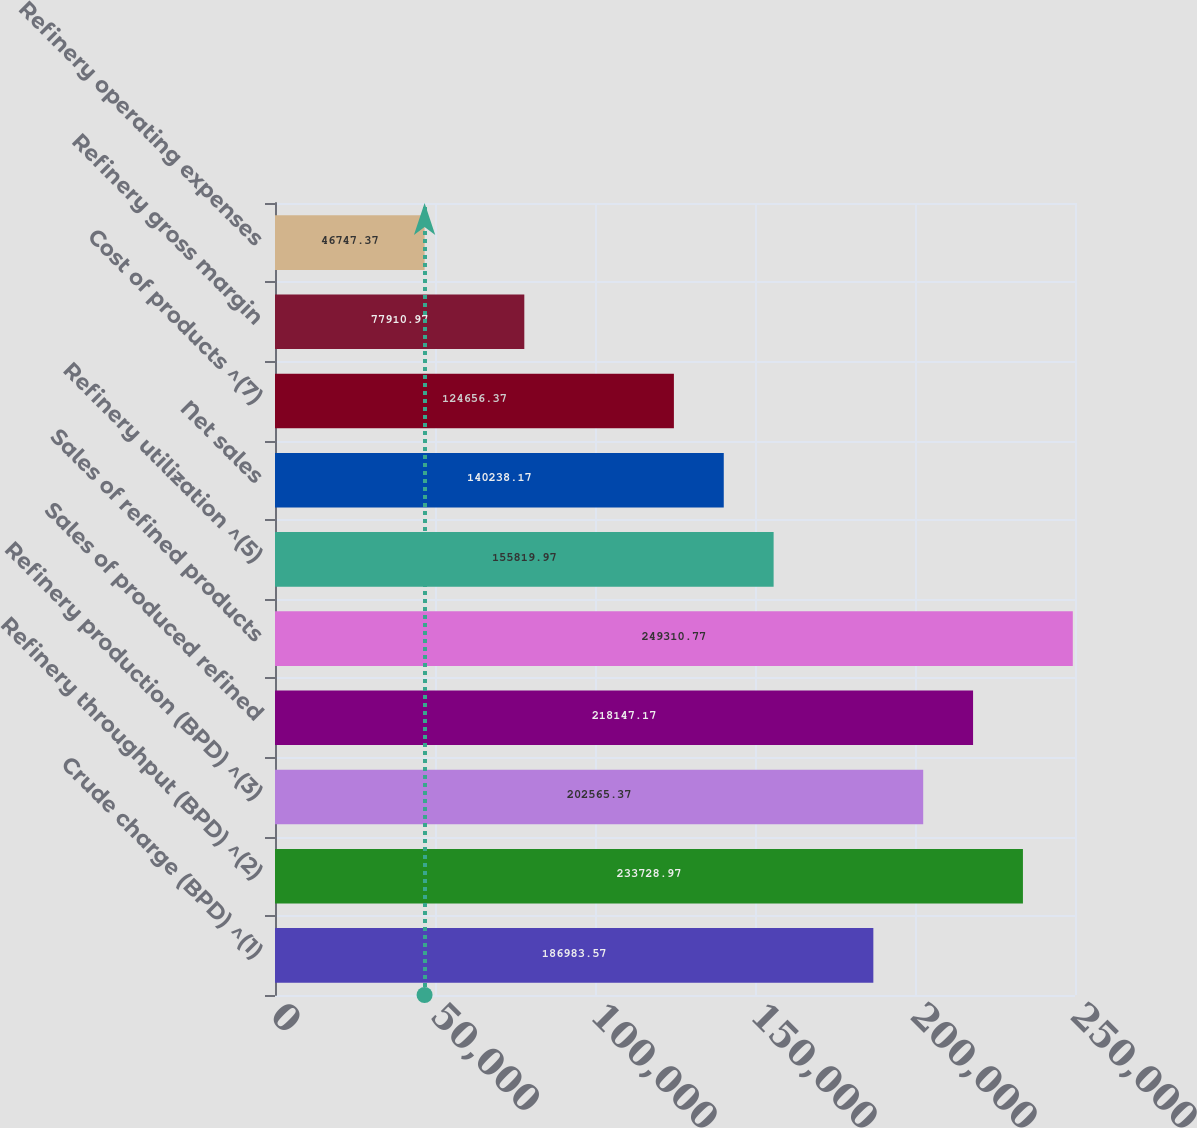<chart> <loc_0><loc_0><loc_500><loc_500><bar_chart><fcel>Crude charge (BPD) ^(1)<fcel>Refinery throughput (BPD) ^(2)<fcel>Refinery production (BPD) ^(3)<fcel>Sales of produced refined<fcel>Sales of refined products<fcel>Refinery utilization ^(5)<fcel>Net sales<fcel>Cost of products ^(7)<fcel>Refinery gross margin<fcel>Refinery operating expenses<nl><fcel>186984<fcel>233729<fcel>202565<fcel>218147<fcel>249311<fcel>155820<fcel>140238<fcel>124656<fcel>77911<fcel>46747.4<nl></chart> 